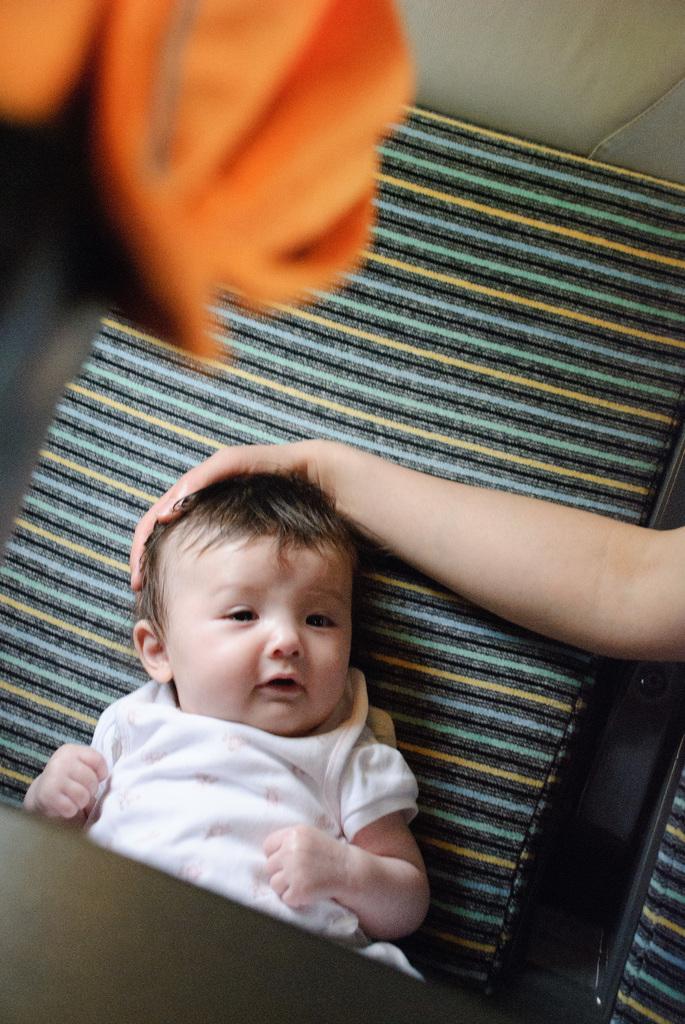How would you summarize this image in a sentence or two? Here we can see a kid and a hand of a person on the platform. 